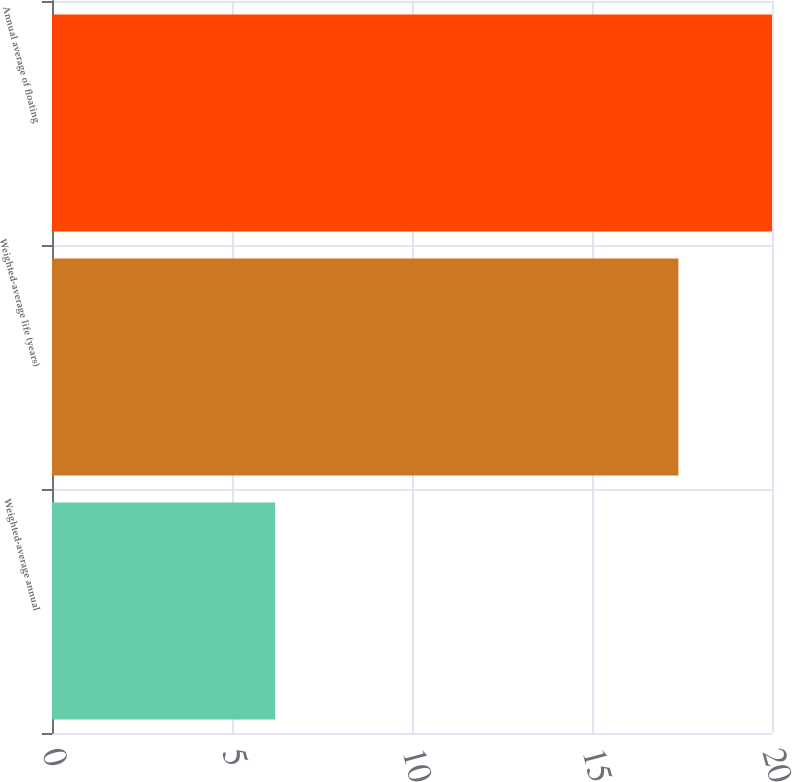<chart> <loc_0><loc_0><loc_500><loc_500><bar_chart><fcel>Weighted-average annual<fcel>Weighted-average life (years)<fcel>Annual average of floating<nl><fcel>6.2<fcel>17.4<fcel>20<nl></chart> 